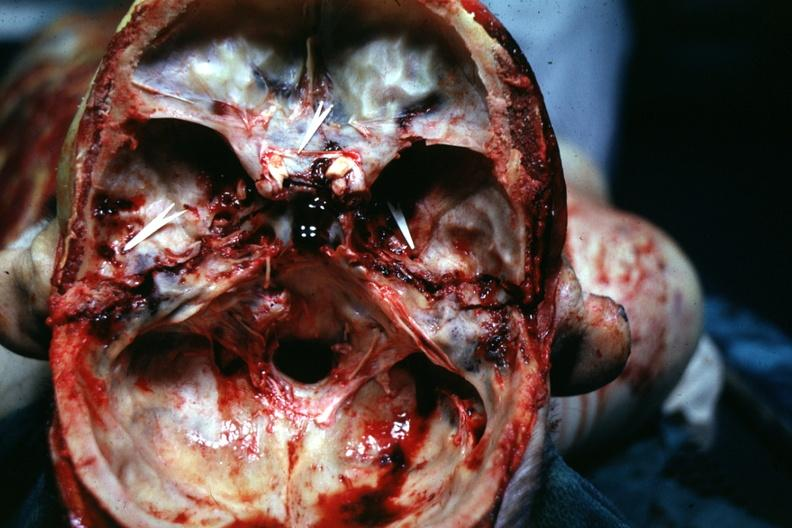s bone, calvarium present?
Answer the question using a single word or phrase. Yes 